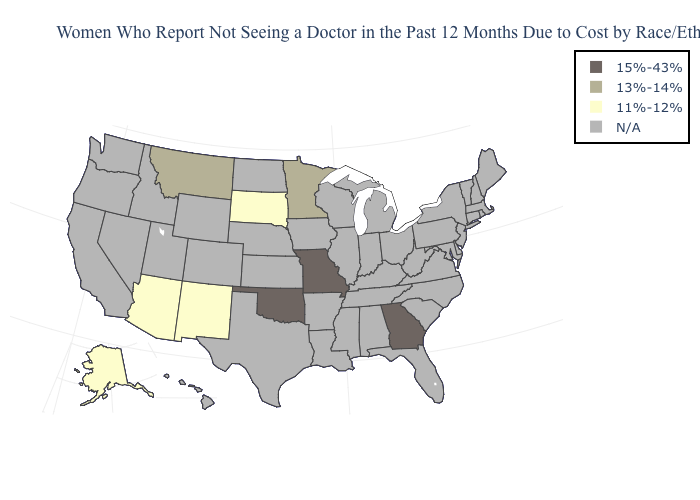Which states hav the highest value in the West?
Answer briefly. Montana. How many symbols are there in the legend?
Concise answer only. 4. Does the first symbol in the legend represent the smallest category?
Quick response, please. No. What is the value of Nevada?
Answer briefly. N/A. Name the states that have a value in the range 15%-43%?
Keep it brief. Georgia, Missouri, Oklahoma. Which states have the highest value in the USA?
Quick response, please. Georgia, Missouri, Oklahoma. Name the states that have a value in the range 15%-43%?
Keep it brief. Georgia, Missouri, Oklahoma. Is the legend a continuous bar?
Give a very brief answer. No. Does Georgia have the lowest value in the USA?
Keep it brief. No. What is the value of California?
Quick response, please. N/A. What is the value of Maryland?
Keep it brief. N/A. Among the states that border North Carolina , which have the highest value?
Quick response, please. Georgia. What is the value of Missouri?
Write a very short answer. 15%-43%. 